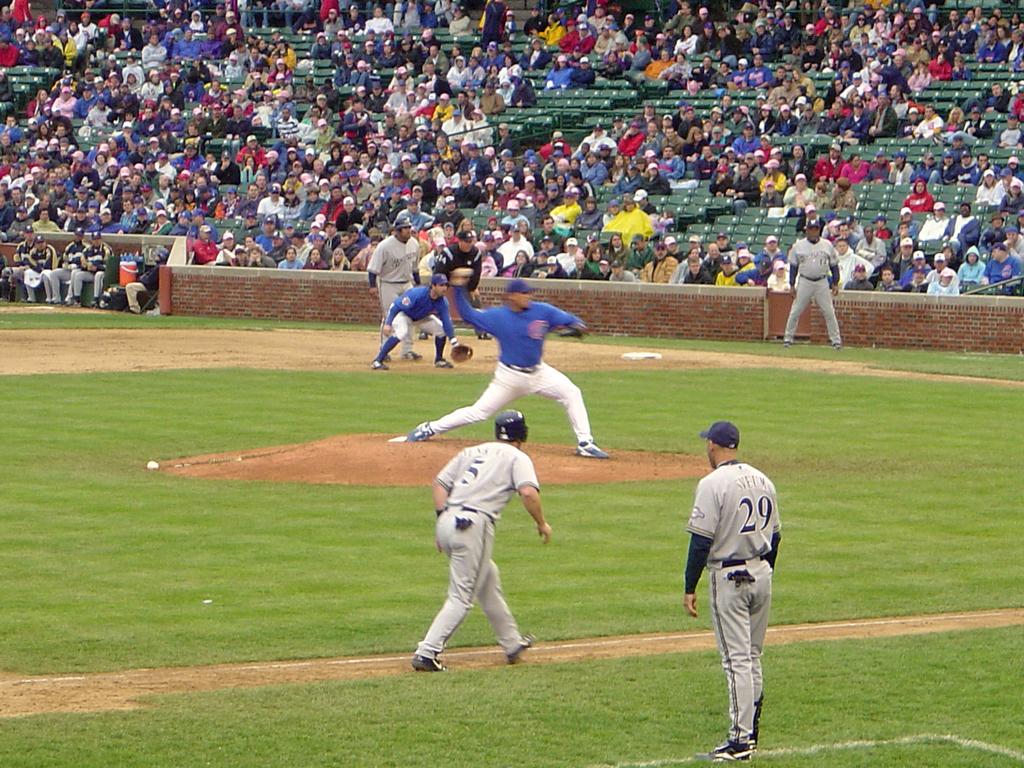What is the jersey number of the guy running?
Provide a short and direct response. 5. What number is the guy on the right?
Your answer should be very brief. 29. 